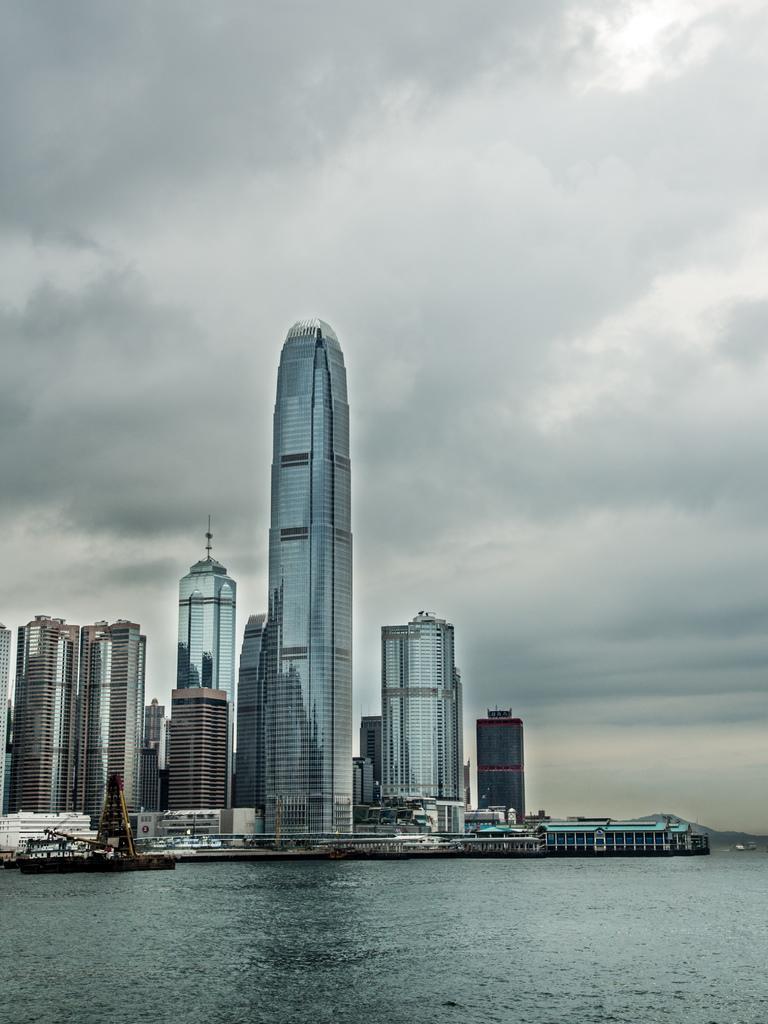Can you describe this image briefly? In this image there is a sea, on that sea there are sheep, in the background there are buildings and cloudy sky. 